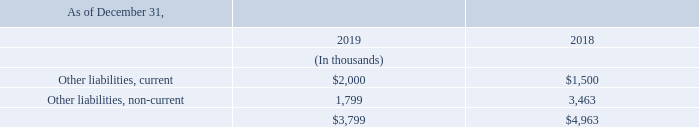NOTE 6 – OTHER LIABILITIES
As described in Note 4, the Company and Finjan Blue entered into a Patent Assignment Agreement with IBM.The components of other liabilities are as presented below:
What are the respective values of other current liabilities in 2019 and 2018?
Answer scale should be: thousand. $2,000, $1,500. What are the respective values of other non-current liabilities in 2019 and 2018?
Answer scale should be: thousand. 1,799, 3,463. What are the respective values of total other liabilities in 2019 and 2018?
Answer scale should be: thousand. $3,799, $4,963. What is the average other current liabilities in 2018 and 2019?
Answer scale should be: thousand. (2,000+1,500)/2 
Answer: 1750. What is the value of other current liabilities as a percentage of the total other liabilities in 2019?
Answer scale should be: percent. 2,000/3,799 
Answer: 52.65. What is the average total other liabilities in 2018 and 2019?
Answer scale should be: thousand. (3,799 + 4,963)/2 
Answer: 4381. 